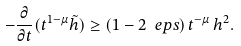Convert formula to latex. <formula><loc_0><loc_0><loc_500><loc_500>- \frac { \partial } { \partial t } ( t ^ { 1 - \mu } \tilde { h } ) \geq ( 1 - 2 \ e p s ) \, t ^ { - \mu } \, h ^ { 2 } .</formula> 